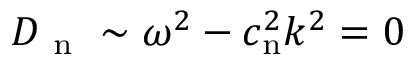Convert formula to latex. <formula><loc_0><loc_0><loc_500><loc_500>D _ { n } \sim \omega ^ { 2 } - c _ { n } ^ { 2 } k ^ { 2 } = 0</formula> 